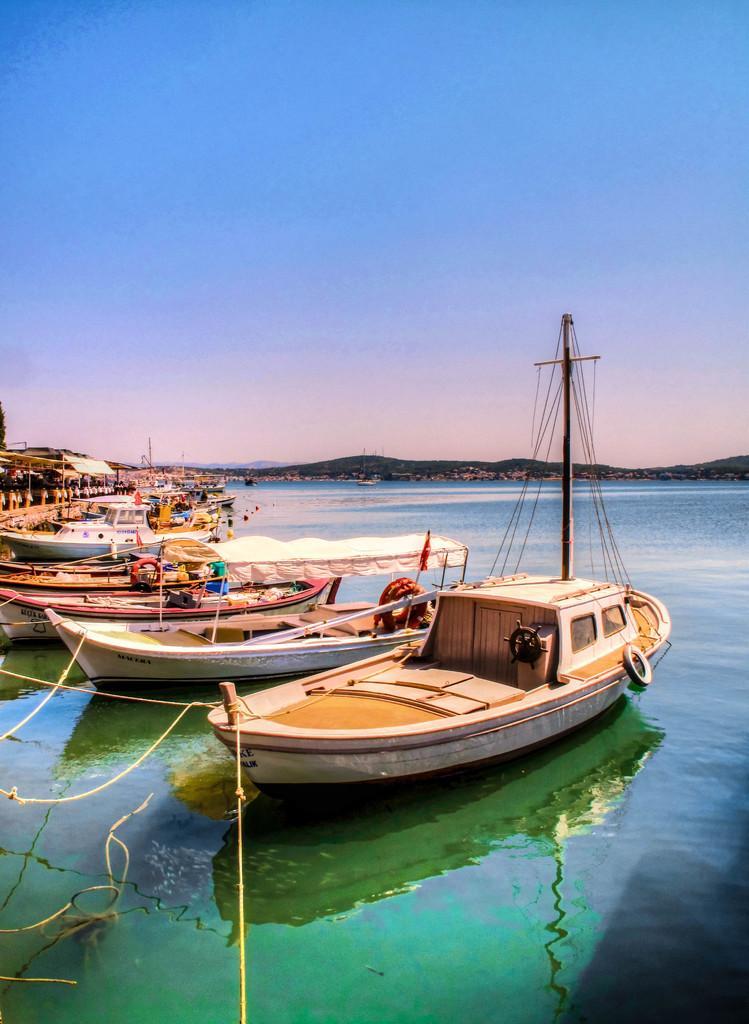Please provide a concise description of this image. In this image I can see few boats in water they are in white color, at back I can see mountains and sky is in white and blue color. 